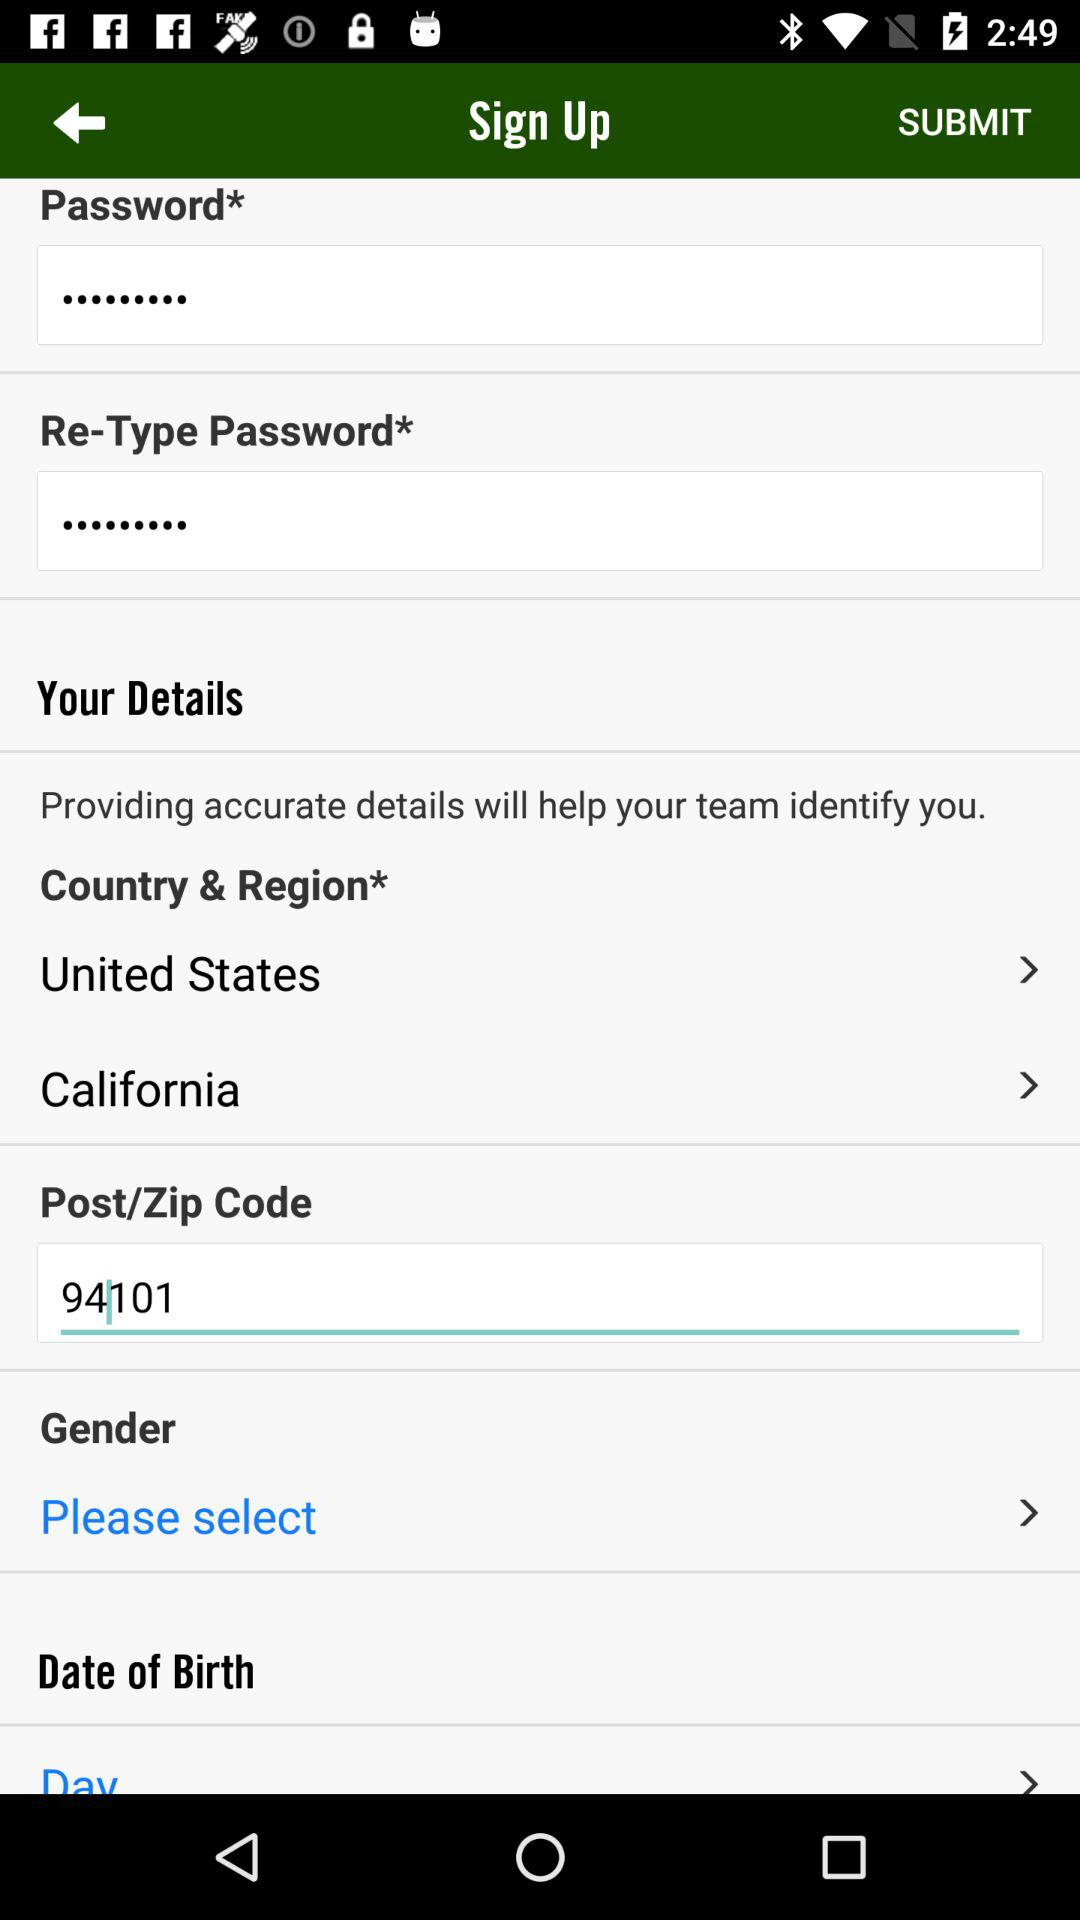What is the country's name? The country's name is the "United States". 